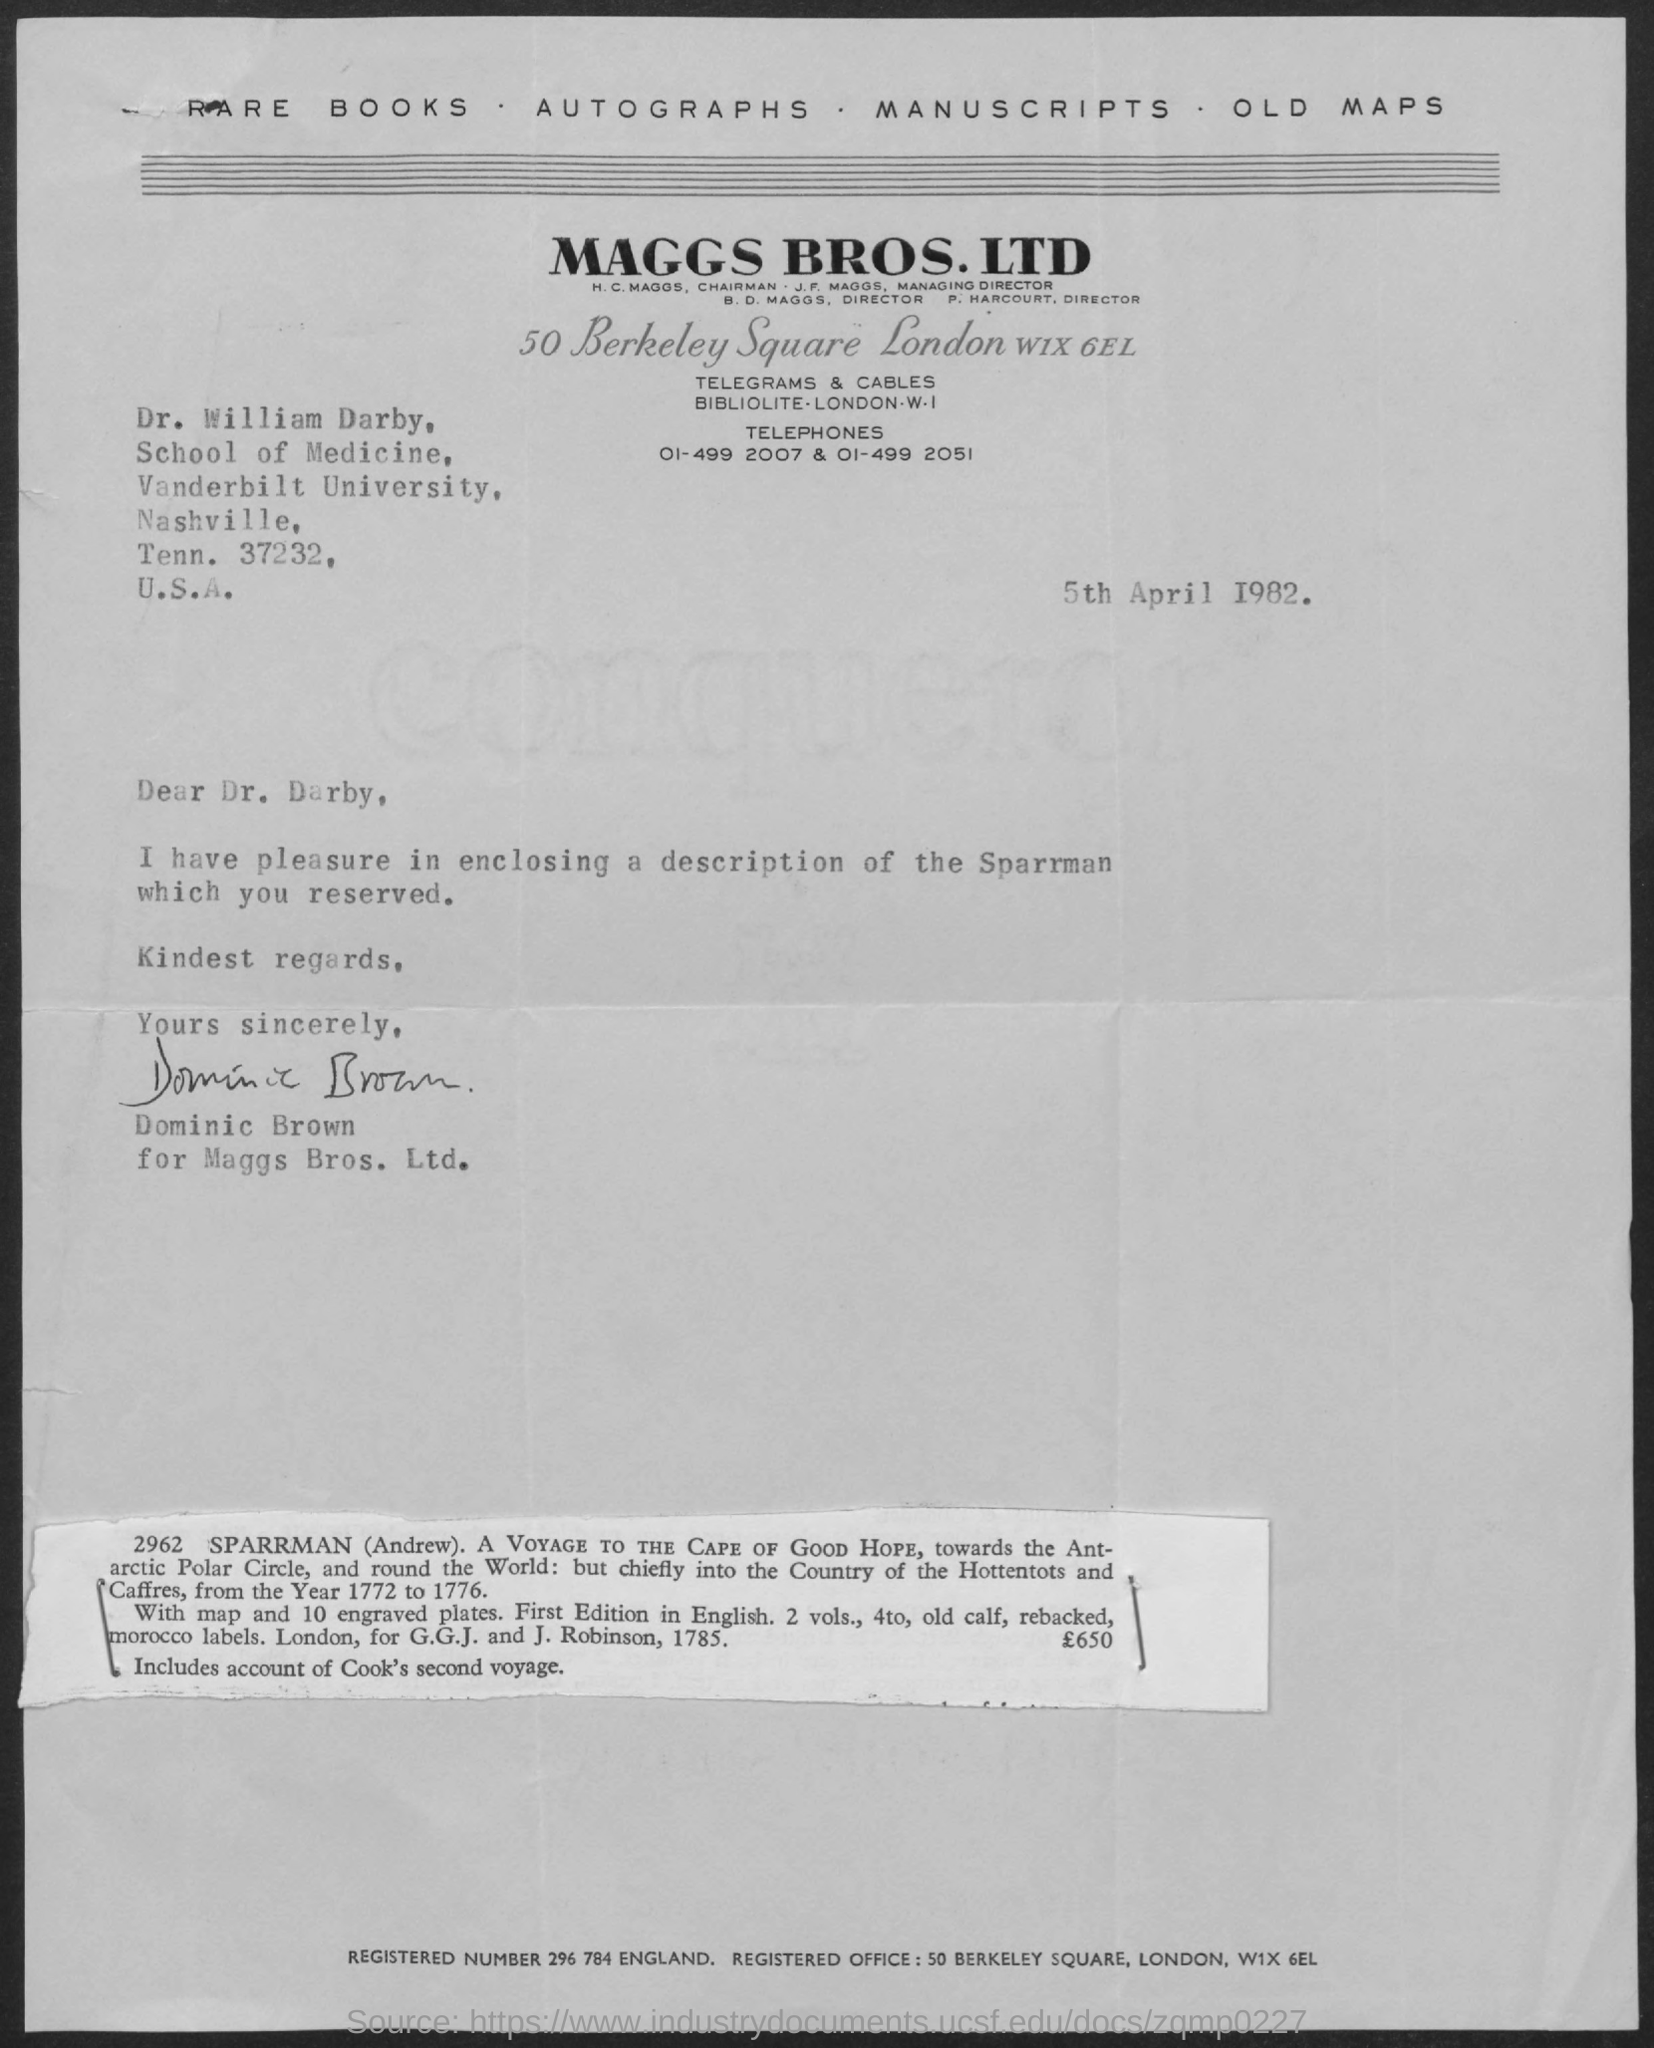Specify some key components in this picture. The letter is dated April 5th, 1982. The letter is from Dominic Brown. MAGGS BROS. LTD. is the firm that is mentioned at the top of the page. The letter is addressed to Dr. William Darby. 